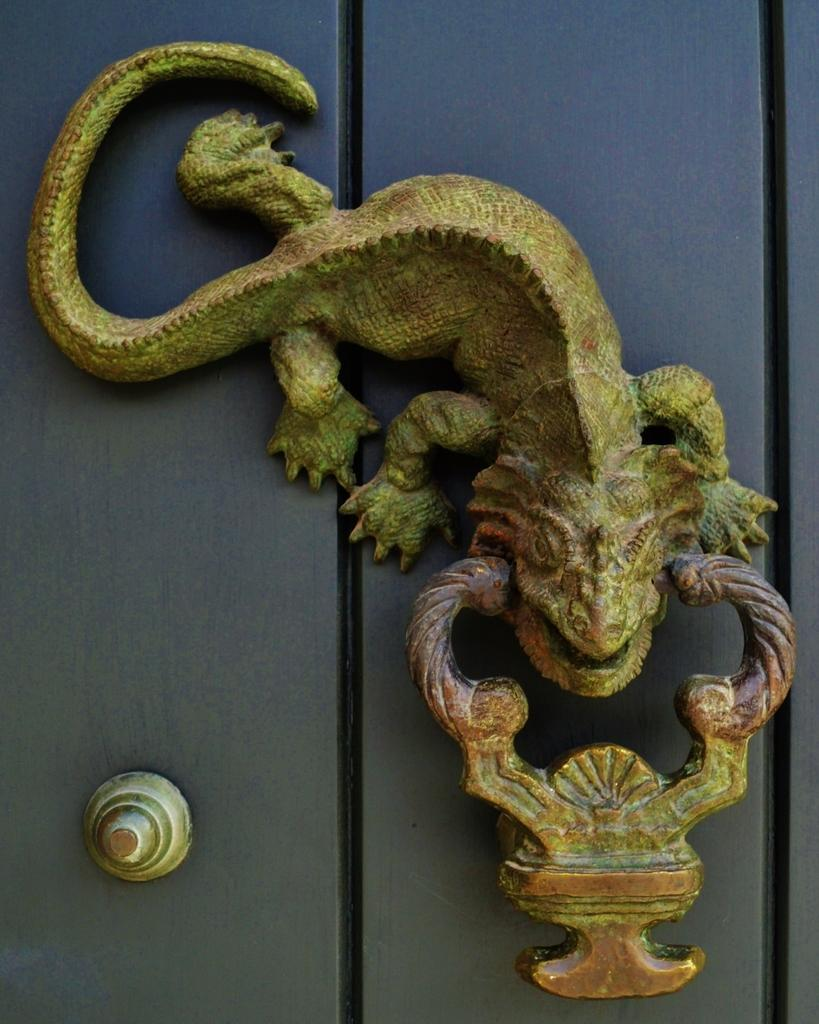What is depicted on the wall in the image? There are sculptures on the wall in the image. What type of juice is being served in the image? There is no juice or any indication of a drink being served in the image; it only features sculptures on the wall. 